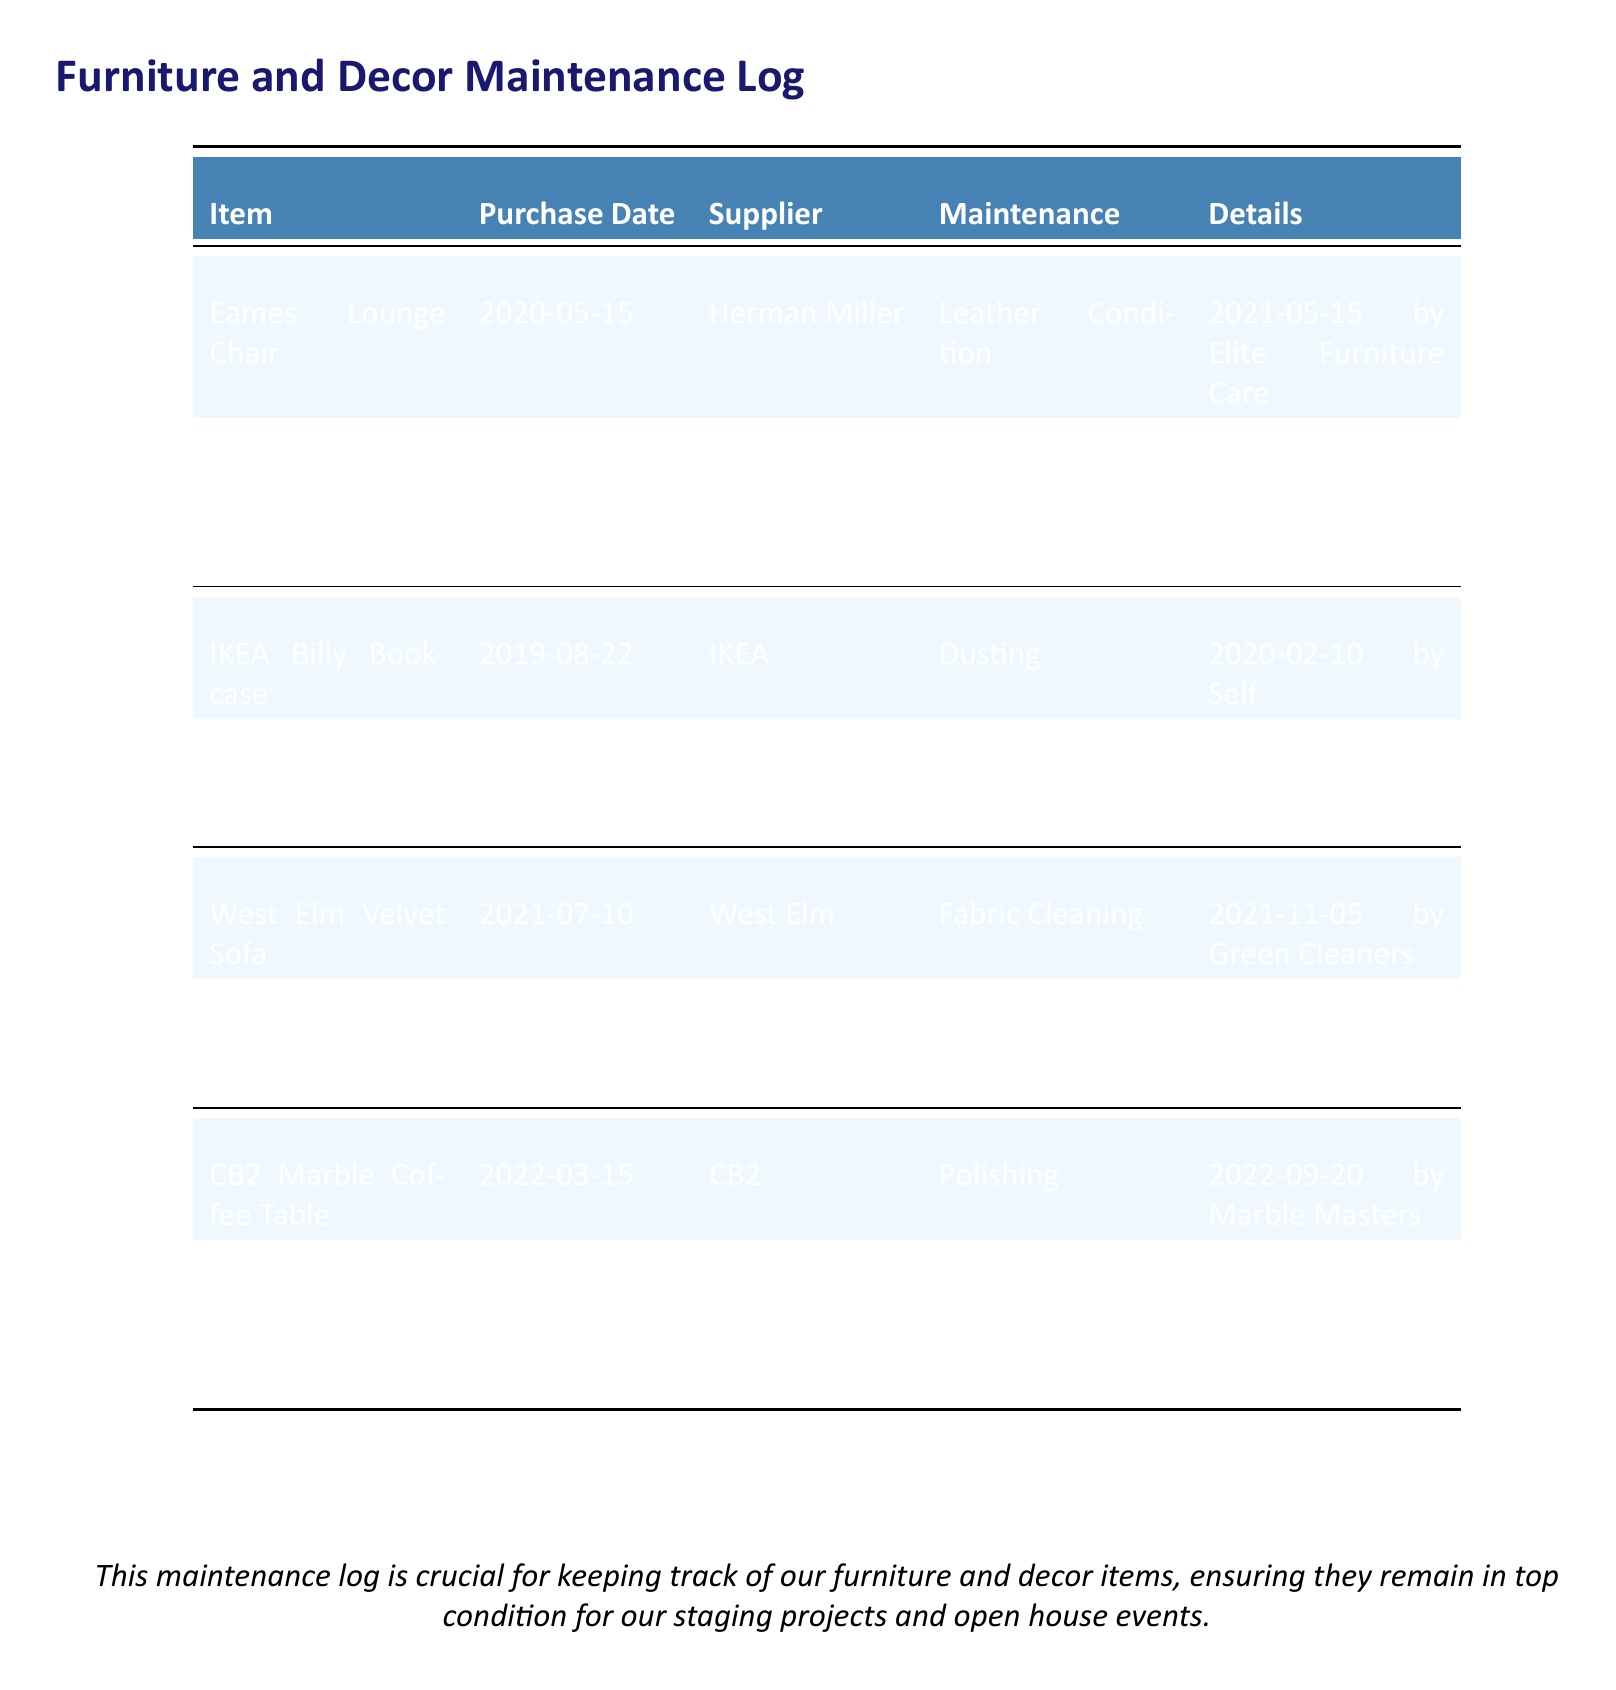What is the purchase date of the Eames Lounge Chair? The purchase date of the Eames Lounge Chair is found in the document under the Purchase Date column.
Answer: 2020-05-15 Who is the supplier of the West Elm Velvet Sofa? The supplier of the West Elm Velvet Sofa can be found in the Supplier column next to the item name.
Answer: West Elm What maintenance activity was performed on the IKEA Billy Bookcase on 2021-06-18? The maintenance activity for the IKEA Billy Bookcase on that date can be found in the Maintenance column corresponding to the date.
Answer: Shelves Adjustment How many maintenance activities have been recorded for the CB2 Marble Coffee Table? By counting the entries in the Maintenance column for the CB2 Marble Coffee Table, we can determine the number.
Answer: 2 What type of cleaning was done on the West Elm Velvet Sofa? The type of cleaning can be found in the Maintenance column next to the West Elm Velvet Sofa entry.
Answer: Fabric Cleaning Which service performed the Leather Condition maintenance for the Eames Lounge Chair? The service responsible for that maintenance can be located in the Details column next to the Leather Condition entry.
Answer: Elite Furniture Care When was the legs tightening for the CB2 Marble Coffee Table performed? The date of the legs tightening activity can be found in the Maintenance column for the CB2 Marble Coffee Table.
Answer: 2023-03-10 How many items in the log have been maintained by the service "Smith Handyman Services"? By reviewing the Maintenance column for entries that mention "Smith Handyman Services", we can find the count.
Answer: 2 